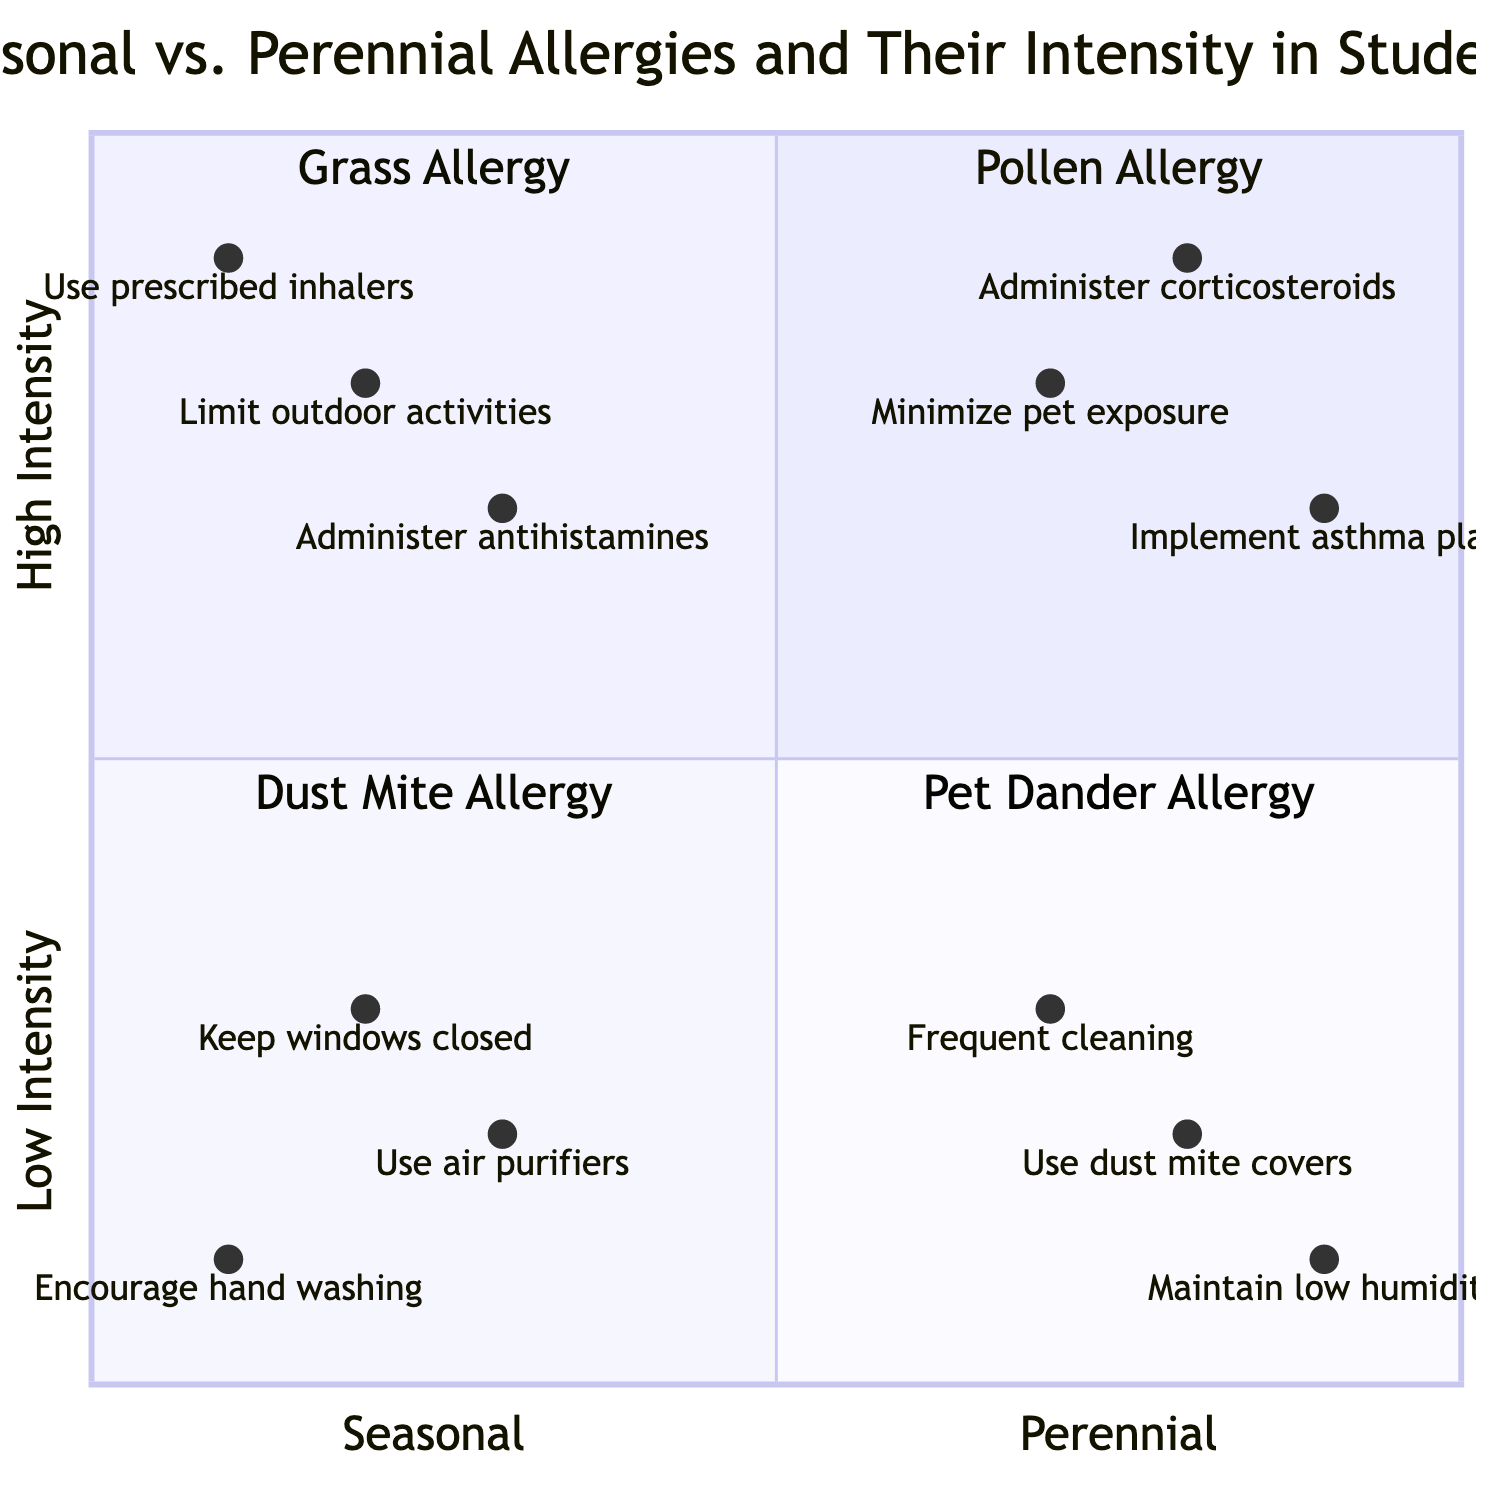What type of allergy is in the top-left quadrant? The top-left quadrant represents seasonal allergies with low intensity. According to the data, the specific allergy type listed in this quadrant is "Pollen Allergy."
Answer: Pollen Allergy How many types of allergies are represented in the chart? The diagram includes four types of allergies: Pollen Allergy, Grass Allergy, Dust Mite Allergy, and Pet Dander Allergy. Therefore, there are four types represented in total.
Answer: Four Which mitigation technique is recommended for Grass Allergy? Grass Allergy is located in the seasonal/high intensity quadrant, and according to the data, the recommended mitigation techniques include "Limit outdoor activities," "Administer antihistamines," and "Use prescribed inhalers." Any of these techniques would be acceptable as an answer.
Answer: Limit outdoor activities What are two symptoms associated with Pet Dander Allergy? Pet Dander Allergy, located in the bottom-right quadrant, is listed as having "Severe Asthma Symptoms" and "Frequent Coughing" as its symptoms. These two symptoms directly correspond to this allergy type in the chart.
Answer: Severe Asthma Symptoms, Frequent Coughing Which allergy requires frequent cleaning as a mitigation technique? The "Frequent cleaning" technique corresponds to Dust Mite Allergy, which is located in the bottom-left quadrant (Perennial/Low intensity). This technique is directly linked to this allergy type based on the information provided.
Answer: Dust Mite Allergy What is the intensity level of Pollen Allergy? Pollen Allergy is situated in the top-left quadrant, which indicates that it is categorized as a low intensity allergy. Hence, the answer reflects the intensity level assigned to this specific allergy.
Answer: Low intensity How do the mitigation techniques differ between perennial and seasonal allergies? Seasonal allergies like Grass Allergy tend to require more immediate action such as limiting outdoor activities compared to perennial allergies like Dust Mite Allergy, which focus on long-term solutions like frequent cleaning. The difference lies in the seasonal versus stable (perennial) nature of the allergies and their corresponding techniques.
Answer: Immediate vs. long-term techniques What quadrant would you find allergies that have high intensity and are perennial? The bottom-right quadrant is designated for perennial allergies with high intensity. According to the chart, this quadrant contains the Pet Dander Allergy. Therefore, the answer specifies the location of these allergy types.
Answer: Bottom-right quadrant Which allergy has the most severe symptoms? Pet Dander Allergy has the most severe symptoms listed: "Severe Asthma Symptoms" and "Frequent Coughing." Therefore, this allergy type is identified as having the most significant effects on health according to the provided data.
Answer: Pet Dander Allergy 